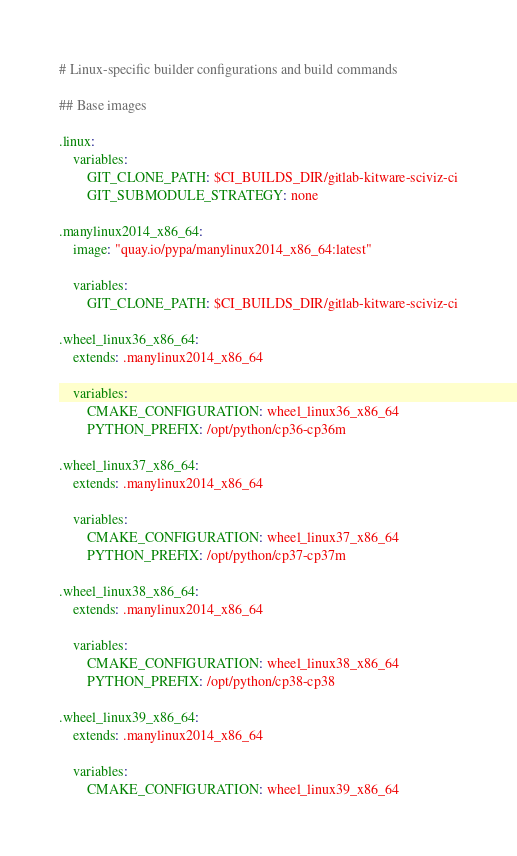<code> <loc_0><loc_0><loc_500><loc_500><_YAML_># Linux-specific builder configurations and build commands

## Base images

.linux:
    variables:
        GIT_CLONE_PATH: $CI_BUILDS_DIR/gitlab-kitware-sciviz-ci
        GIT_SUBMODULE_STRATEGY: none

.manylinux2014_x86_64:
    image: "quay.io/pypa/manylinux2014_x86_64:latest"

    variables:
        GIT_CLONE_PATH: $CI_BUILDS_DIR/gitlab-kitware-sciviz-ci

.wheel_linux36_x86_64:
    extends: .manylinux2014_x86_64

    variables:
        CMAKE_CONFIGURATION: wheel_linux36_x86_64
        PYTHON_PREFIX: /opt/python/cp36-cp36m

.wheel_linux37_x86_64:
    extends: .manylinux2014_x86_64

    variables:
        CMAKE_CONFIGURATION: wheel_linux37_x86_64
        PYTHON_PREFIX: /opt/python/cp37-cp37m

.wheel_linux38_x86_64:
    extends: .manylinux2014_x86_64

    variables:
        CMAKE_CONFIGURATION: wheel_linux38_x86_64
        PYTHON_PREFIX: /opt/python/cp38-cp38

.wheel_linux39_x86_64:
    extends: .manylinux2014_x86_64

    variables:
        CMAKE_CONFIGURATION: wheel_linux39_x86_64</code> 